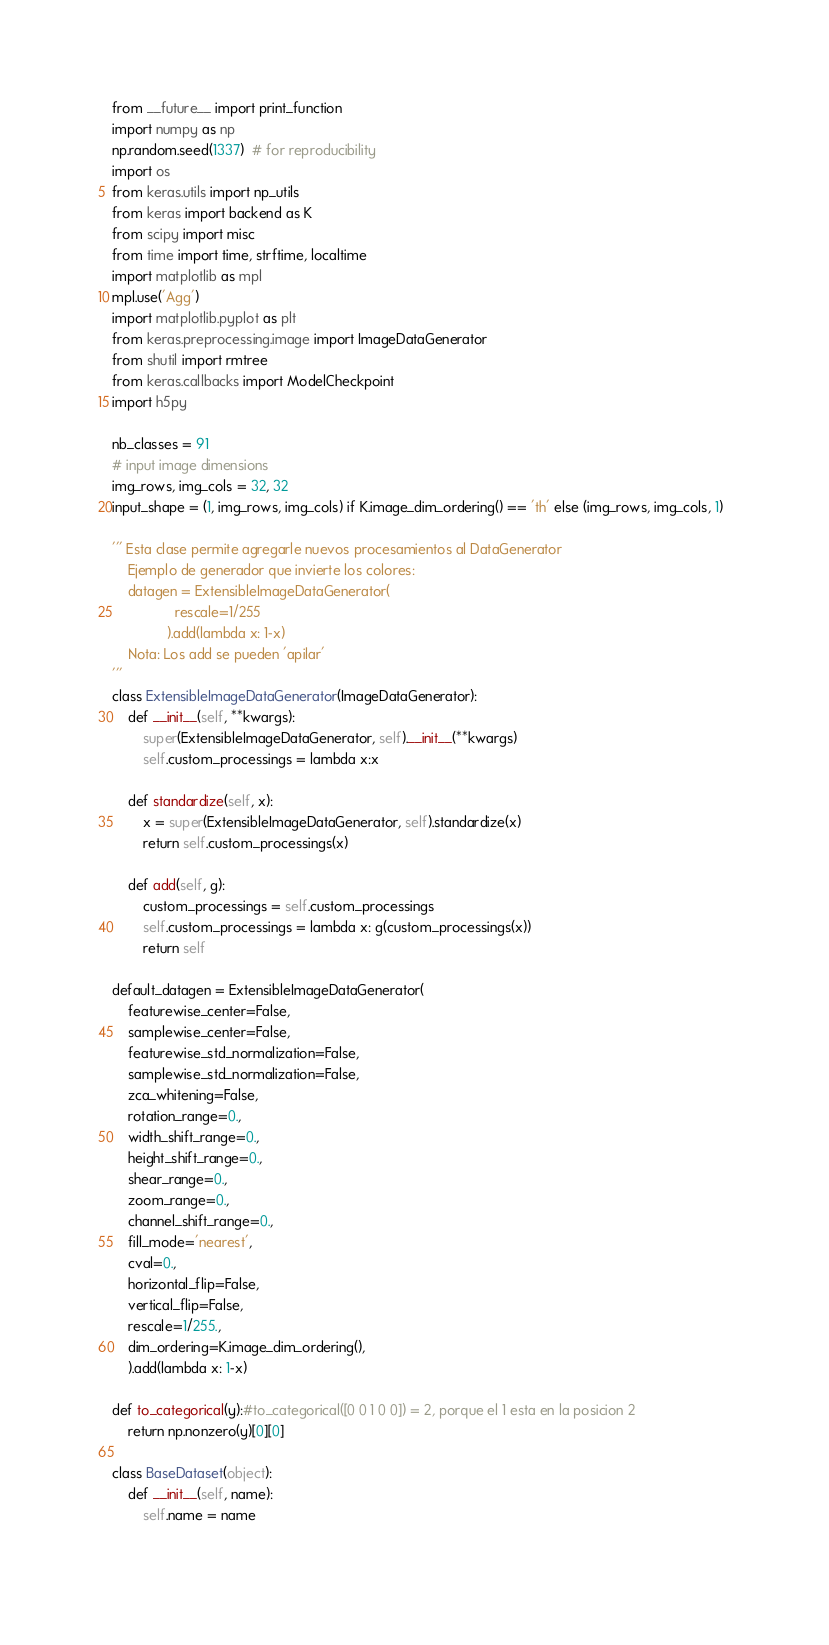Convert code to text. <code><loc_0><loc_0><loc_500><loc_500><_Python_>from __future__ import print_function
import numpy as np
np.random.seed(1337)  # for reproducibility
import os
from keras.utils import np_utils
from keras import backend as K
from scipy import misc
from time import time, strftime, localtime
import matplotlib as mpl
mpl.use('Agg')
import matplotlib.pyplot as plt
from keras.preprocessing.image import ImageDataGenerator
from shutil import rmtree
from keras.callbacks import ModelCheckpoint
import h5py

nb_classes = 91
# input image dimensions
img_rows, img_cols = 32, 32
input_shape = (1, img_rows, img_cols) if K.image_dim_ordering() == 'th' else (img_rows, img_cols, 1)  

''' Esta clase permite agregarle nuevos procesamientos al DataGenerator
    Ejemplo de generador que invierte los colores:
    datagen = ExtensibleImageDataGenerator(
                rescale=1/255
              ).add(lambda x: 1-x)
    Nota: Los add se pueden 'apilar'
'''
class ExtensibleImageDataGenerator(ImageDataGenerator):
    def __init__(self, **kwargs):
        super(ExtensibleImageDataGenerator, self).__init__(**kwargs)
        self.custom_processings = lambda x:x

    def standardize(self, x):
        x = super(ExtensibleImageDataGenerator, self).standardize(x)
        return self.custom_processings(x)

    def add(self, g):
        custom_processings = self.custom_processings
        self.custom_processings = lambda x: g(custom_processings(x))
        return self

default_datagen = ExtensibleImageDataGenerator(
    featurewise_center=False,
    samplewise_center=False,
    featurewise_std_normalization=False,
    samplewise_std_normalization=False,
    zca_whitening=False,
    rotation_range=0.,
    width_shift_range=0.,
    height_shift_range=0.,
    shear_range=0.,
    zoom_range=0.,
    channel_shift_range=0.,
    fill_mode='nearest',
    cval=0.,
    horizontal_flip=False,
    vertical_flip=False,
    rescale=1/255.,
    dim_ordering=K.image_dim_ordering(),
    ).add(lambda x: 1-x)

def to_categorical(y):#to_categorical([0 0 1 0 0]) = 2, porque el 1 esta en la posicion 2
    return np.nonzero(y)[0][0]

class BaseDataset(object):
    def __init__(self, name):
        self.name = name
    </code> 